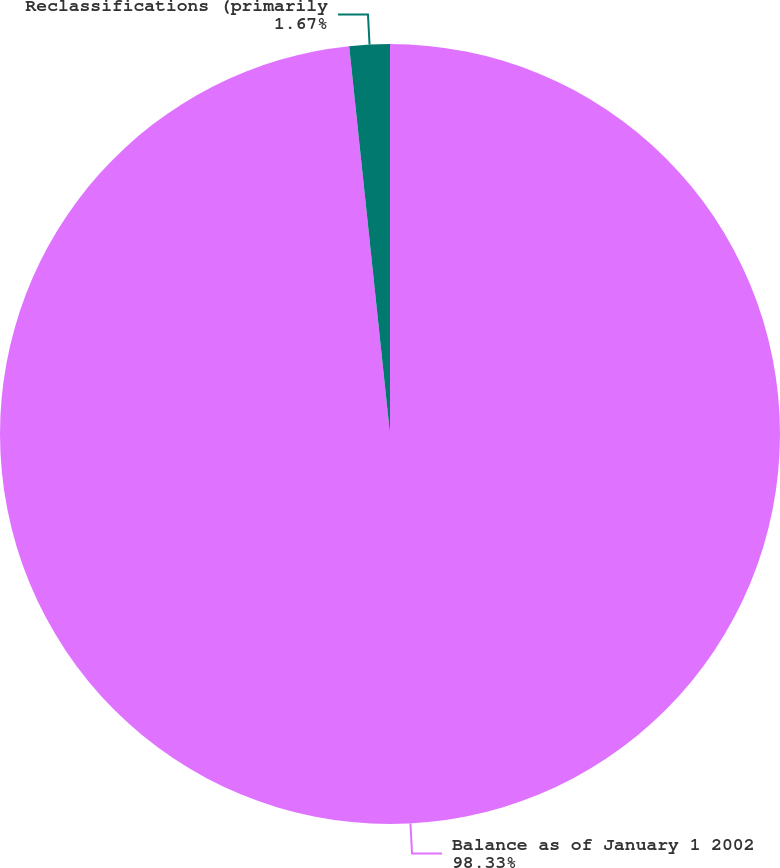Convert chart to OTSL. <chart><loc_0><loc_0><loc_500><loc_500><pie_chart><fcel>Balance as of January 1 2002<fcel>Reclassifications (primarily<nl><fcel>98.33%<fcel>1.67%<nl></chart> 